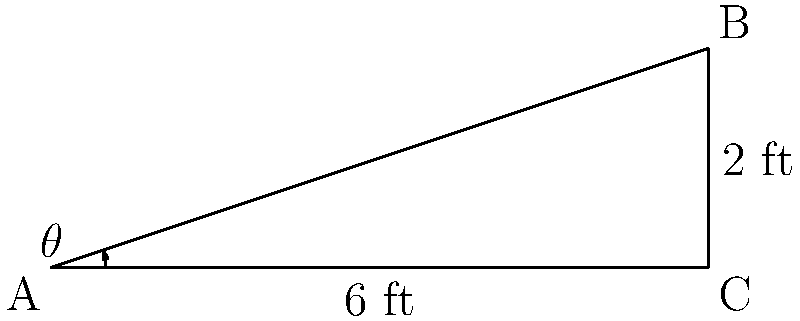As a spa owner, you're installing a new massage table. The table's surface is 6 feet long and rises 2 feet from one end to the other. What is the angle of inclination ($\theta$) of the massage table surface? To find the angle of inclination, we can use the concept of slope and the arctangent function. Let's approach this step-by-step:

1) First, we need to calculate the slope of the table surface.
   Slope = rise / run
   Rise = 2 feet
   Run = 6 feet
   Slope = 2 / 6 = 1 / 3

2) The slope of a line is equal to the tangent of its angle of inclination.
   $\tan(\theta) = \frac{1}{3}$

3) To find $\theta$, we need to take the inverse tangent (arctangent) of the slope:
   $\theta = \arctan(\frac{1}{3})$

4) Using a calculator or trigonometric tables:
   $\theta \approx 18.43^\circ$

5) Rounding to the nearest degree:
   $\theta \approx 18^\circ$

This angle ensures a gentle incline for client comfort while allowing for proper positioning during massage treatments.
Answer: $18^\circ$ 